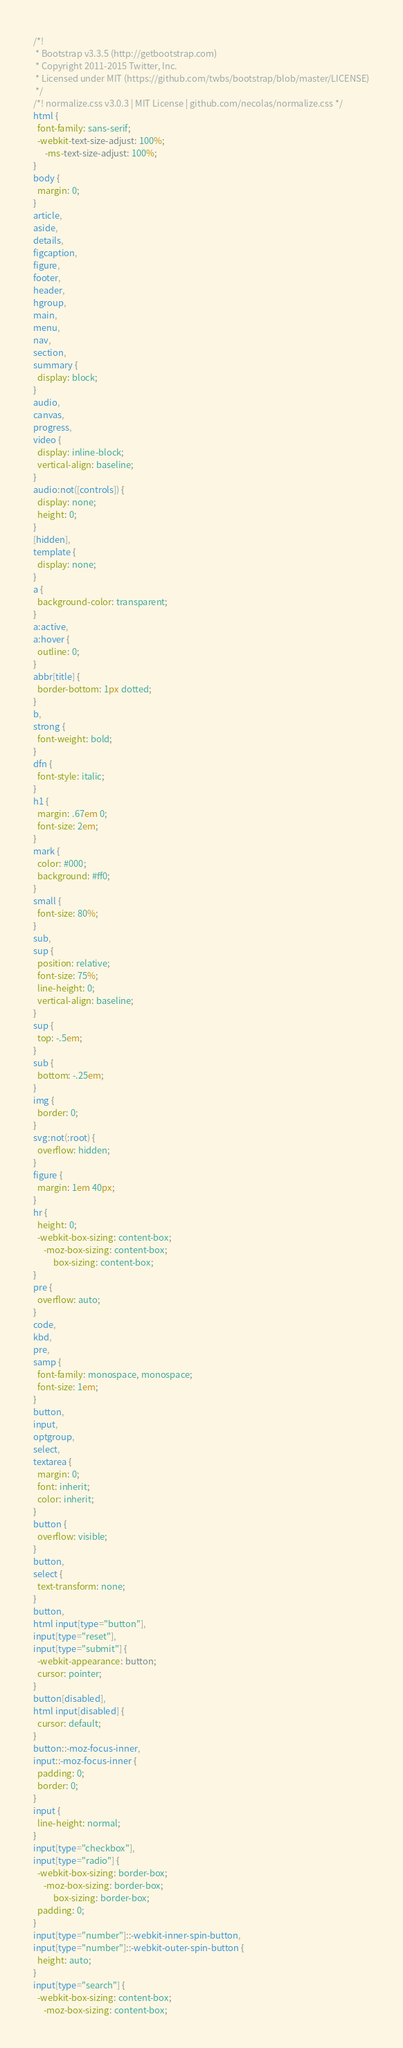<code> <loc_0><loc_0><loc_500><loc_500><_CSS_>/*!
 * Bootstrap v3.3.5 (http://getbootstrap.com)
 * Copyright 2011-2015 Twitter, Inc.
 * Licensed under MIT (https://github.com/twbs/bootstrap/blob/master/LICENSE)
 */
/*! normalize.css v3.0.3 | MIT License | github.com/necolas/normalize.css */
html {
  font-family: sans-serif;
  -webkit-text-size-adjust: 100%;
      -ms-text-size-adjust: 100%;
}
body {
  margin: 0;
}
article,
aside,
details,
figcaption,
figure,
footer,
header,
hgroup,
main,
menu,
nav,
section,
summary {
  display: block;
}
audio,
canvas,
progress,
video {
  display: inline-block;
  vertical-align: baseline;
}
audio:not([controls]) {
  display: none;
  height: 0;
}
[hidden],
template {
  display: none;
}
a {
  background-color: transparent;
}
a:active,
a:hover {
  outline: 0;
}
abbr[title] {
  border-bottom: 1px dotted;
}
b,
strong {
  font-weight: bold;
}
dfn {
  font-style: italic;
}
h1 {
  margin: .67em 0;
  font-size: 2em;
}
mark {
  color: #000;
  background: #ff0;
}
small {
  font-size: 80%;
}
sub,
sup {
  position: relative;
  font-size: 75%;
  line-height: 0;
  vertical-align: baseline;
}
sup {
  top: -.5em;
}
sub {
  bottom: -.25em;
}
img {
  border: 0;
}
svg:not(:root) {
  overflow: hidden;
}
figure {
  margin: 1em 40px;
}
hr {
  height: 0;
  -webkit-box-sizing: content-box;
     -moz-box-sizing: content-box;
          box-sizing: content-box;
}
pre {
  overflow: auto;
}
code,
kbd,
pre,
samp {
  font-family: monospace, monospace;
  font-size: 1em;
}
button,
input,
optgroup,
select,
textarea {
  margin: 0;
  font: inherit;
  color: inherit;
}
button {
  overflow: visible;
}
button,
select {
  text-transform: none;
}
button,
html input[type="button"],
input[type="reset"],
input[type="submit"] {
  -webkit-appearance: button;
  cursor: pointer;
}
button[disabled],
html input[disabled] {
  cursor: default;
}
button::-moz-focus-inner,
input::-moz-focus-inner {
  padding: 0;
  border: 0;
}
input {
  line-height: normal;
}
input[type="checkbox"],
input[type="radio"] {
  -webkit-box-sizing: border-box;
     -moz-box-sizing: border-box;
          box-sizing: border-box;
  padding: 0;
}
input[type="number"]::-webkit-inner-spin-button,
input[type="number"]::-webkit-outer-spin-button {
  height: auto;
}
input[type="search"] {
  -webkit-box-sizing: content-box;
     -moz-box-sizing: content-box;</code> 